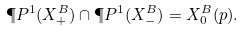<formula> <loc_0><loc_0><loc_500><loc_500>\P P ^ { 1 } ( X ^ { B } _ { + } ) \cap \P P ^ { 1 } ( X ^ { B } _ { - } ) = X ^ { B } _ { 0 } ( p ) .</formula> 